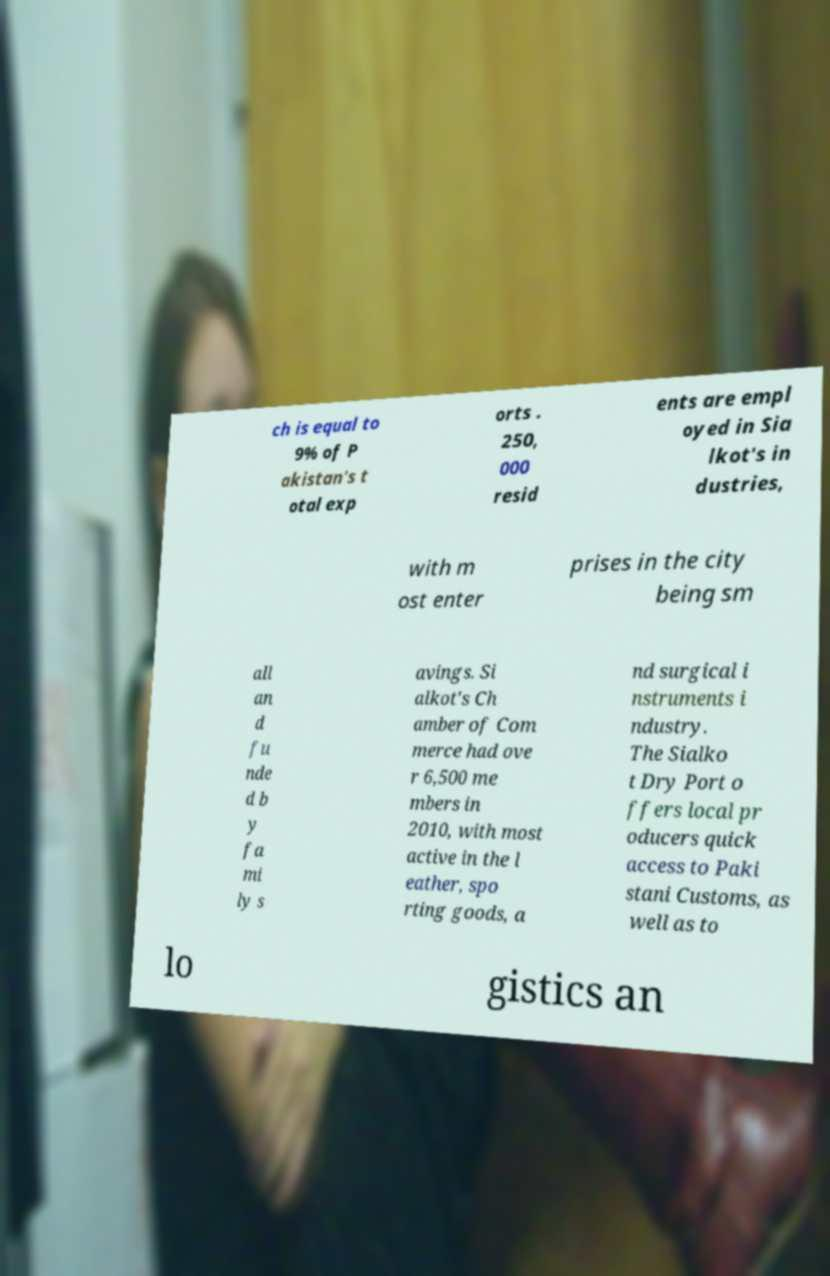For documentation purposes, I need the text within this image transcribed. Could you provide that? ch is equal to 9% of P akistan's t otal exp orts . 250, 000 resid ents are empl oyed in Sia lkot's in dustries, with m ost enter prises in the city being sm all an d fu nde d b y fa mi ly s avings. Si alkot's Ch amber of Com merce had ove r 6,500 me mbers in 2010, with most active in the l eather, spo rting goods, a nd surgical i nstruments i ndustry. The Sialko t Dry Port o ffers local pr oducers quick access to Paki stani Customs, as well as to lo gistics an 